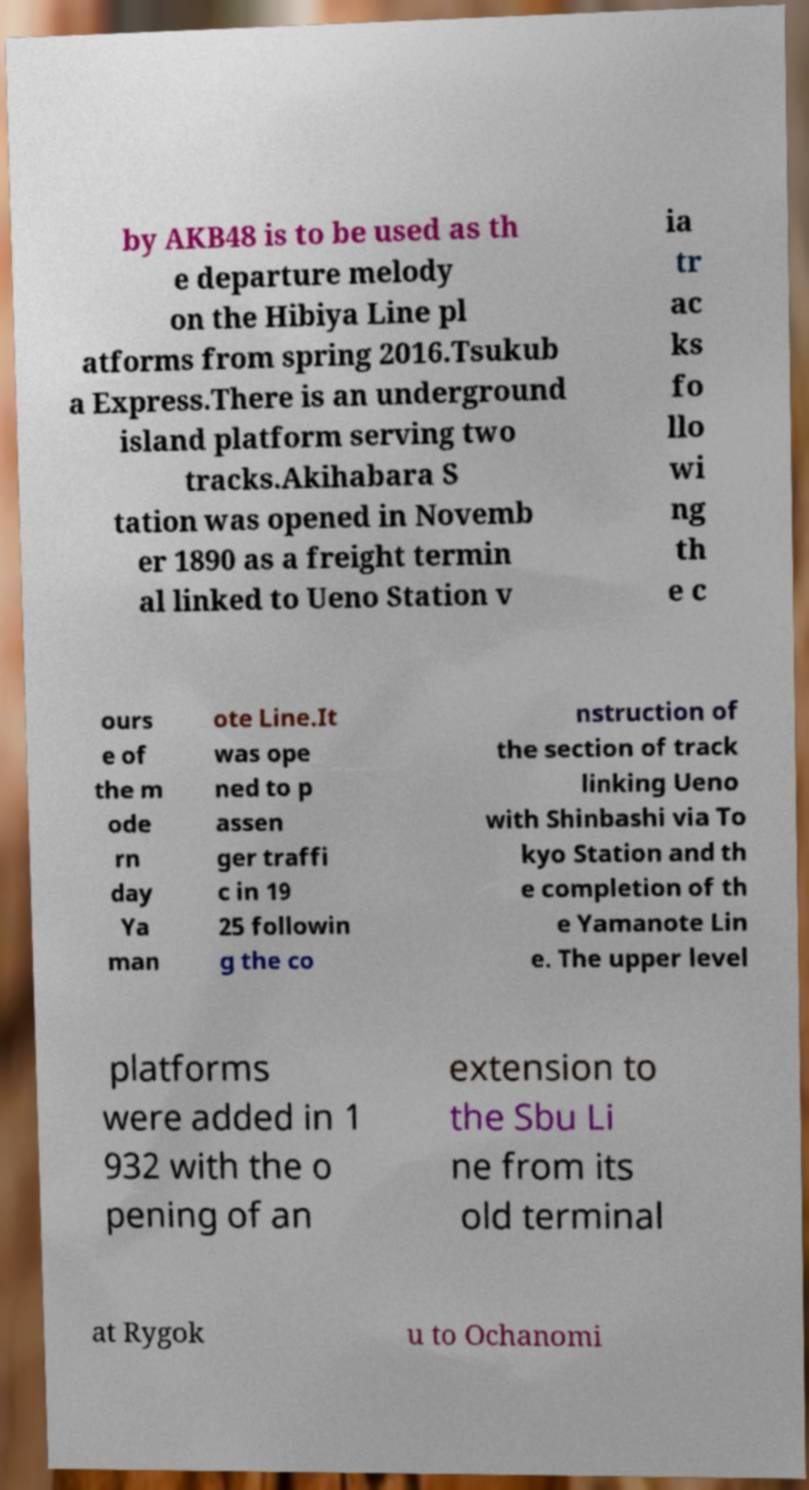For documentation purposes, I need the text within this image transcribed. Could you provide that? by AKB48 is to be used as th e departure melody on the Hibiya Line pl atforms from spring 2016.Tsukub a Express.There is an underground island platform serving two tracks.Akihabara S tation was opened in Novemb er 1890 as a freight termin al linked to Ueno Station v ia tr ac ks fo llo wi ng th e c ours e of the m ode rn day Ya man ote Line.It was ope ned to p assen ger traffi c in 19 25 followin g the co nstruction of the section of track linking Ueno with Shinbashi via To kyo Station and th e completion of th e Yamanote Lin e. The upper level platforms were added in 1 932 with the o pening of an extension to the Sbu Li ne from its old terminal at Rygok u to Ochanomi 